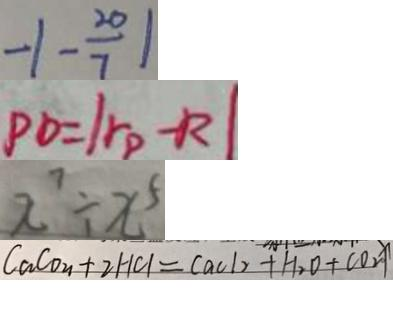<formula> <loc_0><loc_0><loc_500><loc_500>- 1 - \frac { 2 0 } { 7 } \vert 
 P O = \vert r p - R \vert 
 x ^ { 7 } \div x ^ { 5 } 
 C a C o _ { u } + 2 H C l = C a C l _ { 2 } + H _ { 2 } O + C O _ { 2 } \uparrow</formula> 